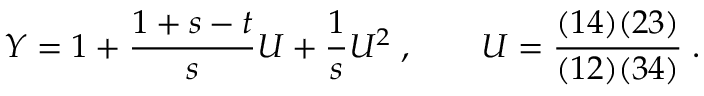Convert formula to latex. <formula><loc_0><loc_0><loc_500><loc_500>Y = 1 + { \frac { 1 + s - t } { s } } U + { \frac { 1 } { s } } U ^ { 2 } \, , \quad U = { \frac { ( 1 4 ) ( 2 3 ) } { ( 1 2 ) ( 3 4 ) } } \, .</formula> 